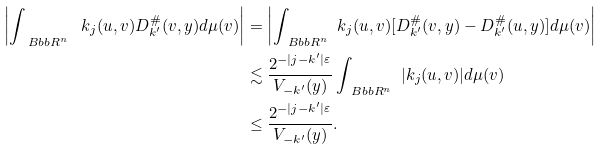<formula> <loc_0><loc_0><loc_500><loc_500>\left | \int _ { \ B b b R ^ { n } } \ k _ { j } ( u , v ) D _ { k ^ { \prime } } ^ { \# } ( v , y ) d \mu ( v ) \right | & = \left | \int _ { \ B b b R ^ { n } } \ k _ { j } ( u , v ) [ D _ { k ^ { \prime } } ^ { \# } ( v , y ) - D _ { k ^ { \prime } } ^ { \# } ( u , y ) ] d \mu ( v ) \right | \\ & \lesssim \frac { 2 ^ { - | j - k ^ { \prime } | \varepsilon } } { V _ { - k ^ { \prime } } ( y ) } \int _ { \ B b b R ^ { n } } \ | k _ { j } ( u , v ) | d \mu ( v ) \\ & \leq \frac { 2 ^ { - | j - k ^ { \prime } | \varepsilon } } { V _ { - k ^ { \prime } } ( y ) } .</formula> 